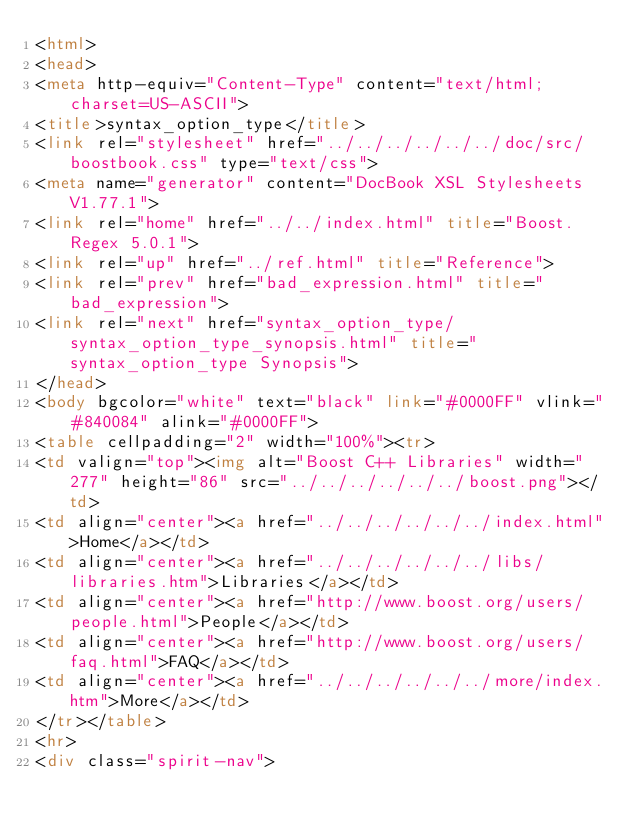Convert code to text. <code><loc_0><loc_0><loc_500><loc_500><_HTML_><html>
<head>
<meta http-equiv="Content-Type" content="text/html; charset=US-ASCII">
<title>syntax_option_type</title>
<link rel="stylesheet" href="../../../../../../doc/src/boostbook.css" type="text/css">
<meta name="generator" content="DocBook XSL Stylesheets V1.77.1">
<link rel="home" href="../../index.html" title="Boost.Regex 5.0.1">
<link rel="up" href="../ref.html" title="Reference">
<link rel="prev" href="bad_expression.html" title="bad_expression">
<link rel="next" href="syntax_option_type/syntax_option_type_synopsis.html" title="syntax_option_type Synopsis">
</head>
<body bgcolor="white" text="black" link="#0000FF" vlink="#840084" alink="#0000FF">
<table cellpadding="2" width="100%"><tr>
<td valign="top"><img alt="Boost C++ Libraries" width="277" height="86" src="../../../../../../boost.png"></td>
<td align="center"><a href="../../../../../../index.html">Home</a></td>
<td align="center"><a href="../../../../../../libs/libraries.htm">Libraries</a></td>
<td align="center"><a href="http://www.boost.org/users/people.html">People</a></td>
<td align="center"><a href="http://www.boost.org/users/faq.html">FAQ</a></td>
<td align="center"><a href="../../../../../../more/index.htm">More</a></td>
</tr></table>
<hr>
<div class="spirit-nav"></code> 